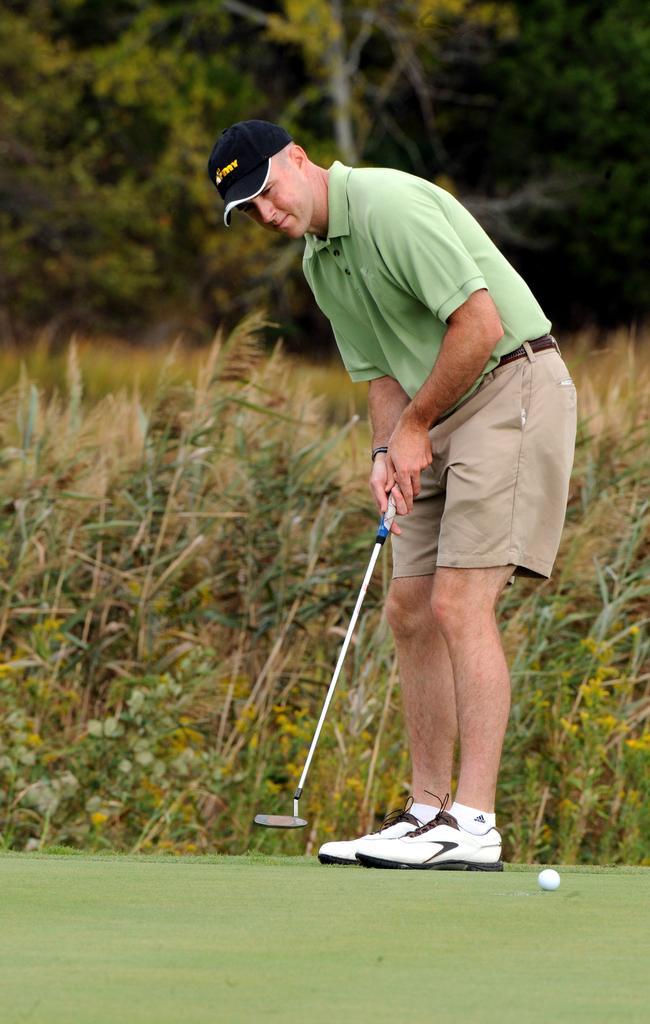Can you describe this image briefly? In this picture there is a man on the right side of the image, by holding a golf stick in his hand and there is a ball on the floor and there is greenery in the background area of the image. 